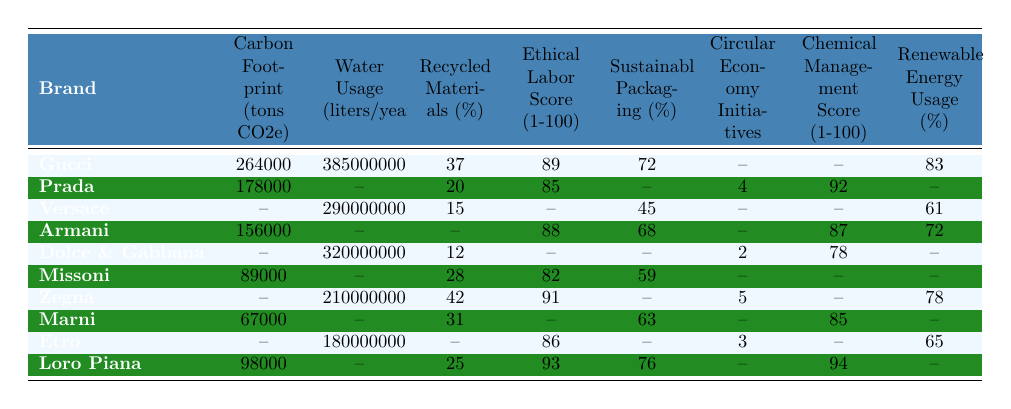What is the carbon footprint of Gucci? The table shows that Gucci has a carbon footprint of 264,000 tons CO2e.
Answer: 264000 Which brand has the highest ethical labor score? By comparing the ethical labor scores listed, Loro Piana has the highest score at 93.
Answer: Loro Piana What is the water usage of Dolce & Gabbana? The table indicates that Dolce & Gabbana has a water usage of 320,000,000 liters per year.
Answer: 320000000 How many brands use renewable energy at least 70%? The brands with renewable energy usage of at least 70% are Gucci (83%), Armani (72%), Zegna (78%), and Loro Piana (none listed). This totals 3.
Answer: 3 What is the average recycled materials percentage among the listed brands? To find the average, add the percentages of recycled materials: 37 + 20 + 15 + 0 + 12 + 28 + 42 + 31 + 0 + 25 = 210. There are 8 brands with values, so the average is 210/8 = 26.25.
Answer: 26.25 Does Versace have an ethical labor score listed? The table shows that Versace does not have an ethical labor score listed.
Answer: No Which brand has higher recycled materials, Missoni or Marni? Missoni has 28% recycled materials, while Marni has 31%. Comparing these shows Marni has the higher percentage.
Answer: Marni What is the total water usage of all brands listed? By adding all the water usage values from the table: 385000000 + 290000000 + 320000000 + 210000000 + 180000000 = 1385000000 liters/year, where some brands do not have water usage recorded.
Answer: 1385000000 What percentage of recycled materials does Zegna use compared to Dolce & Gabbana? Zegna uses 42% recycled materials while Dolce & Gabbana uses 12%. The difference is 42% - 12% = 30%.
Answer: 30 Which brand uses the least water? The brands listed for their water usage are Gucci, Dolce & Gabbana, Versace, Zegna, and Etro. The least usage is by Zegna at 210,000,000 liters/year.
Answer: Zegna 